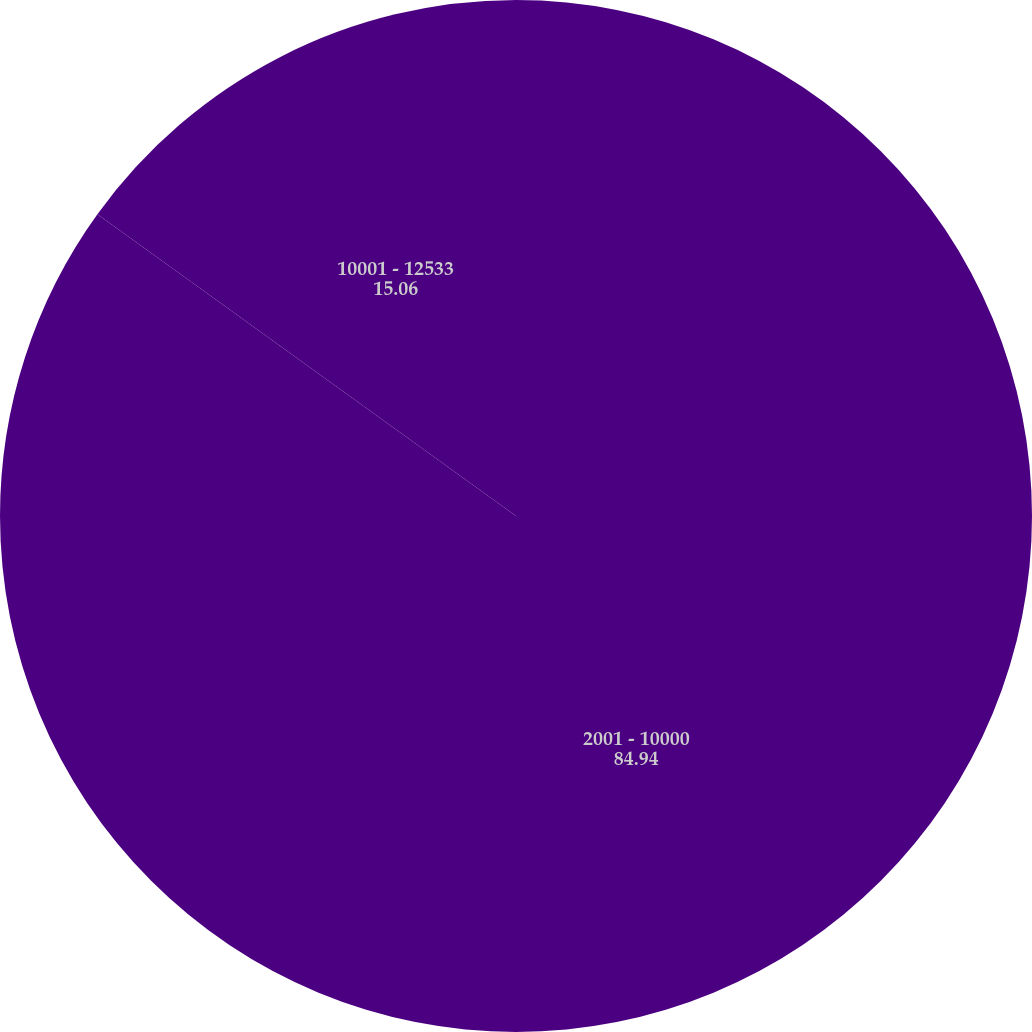Convert chart. <chart><loc_0><loc_0><loc_500><loc_500><pie_chart><fcel>2001 - 10000<fcel>10001 - 12533<nl><fcel>84.94%<fcel>15.06%<nl></chart> 